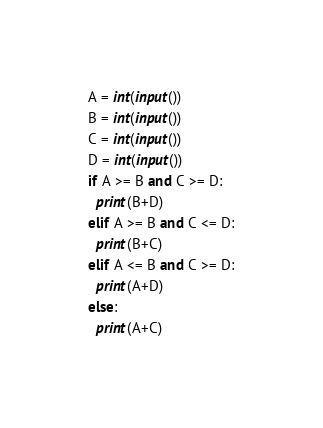Convert code to text. <code><loc_0><loc_0><loc_500><loc_500><_Python_>A = int(input())
B = int(input())
C = int(input())
D = int(input())
if A >= B and C >= D:
  print(B+D)
elif A >= B and C <= D:
  print(B+C)
elif A <= B and C >= D:
  print(A+D)
else:
  print(A+C)</code> 